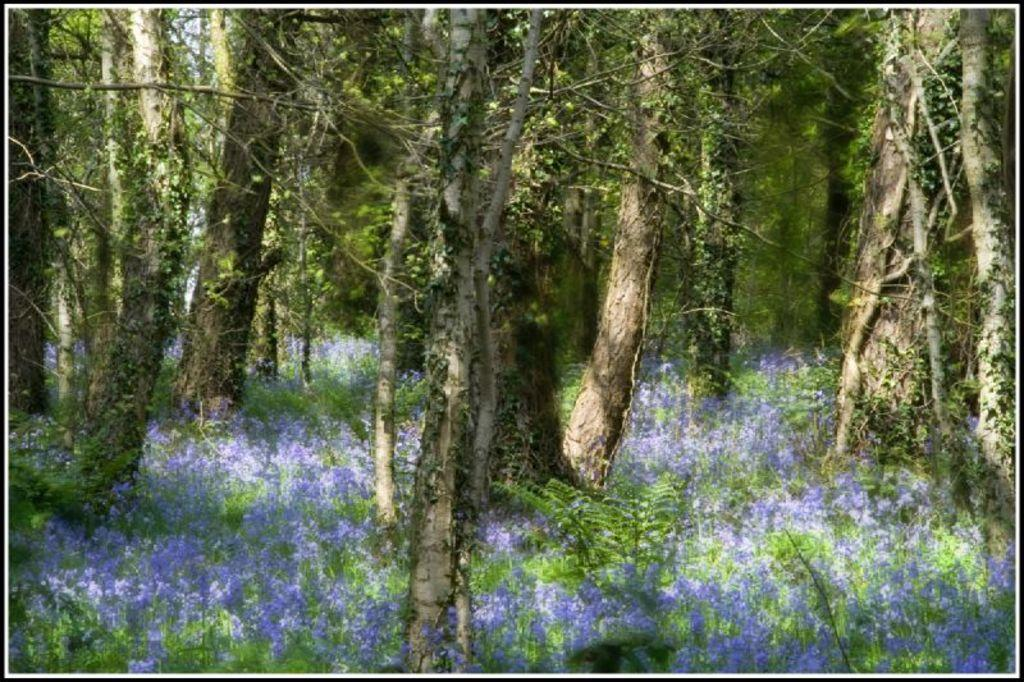What type of vegetation can be seen in the image? There are trees and plants in the image. What color are the flowers on the plants? The flowers on the plants are in lavender color. What type of question is being asked in the image? There is no question present in the image; it features trees, plants, and flowers. Can you see a guitar in the image? No, there is no guitar present in the image. 